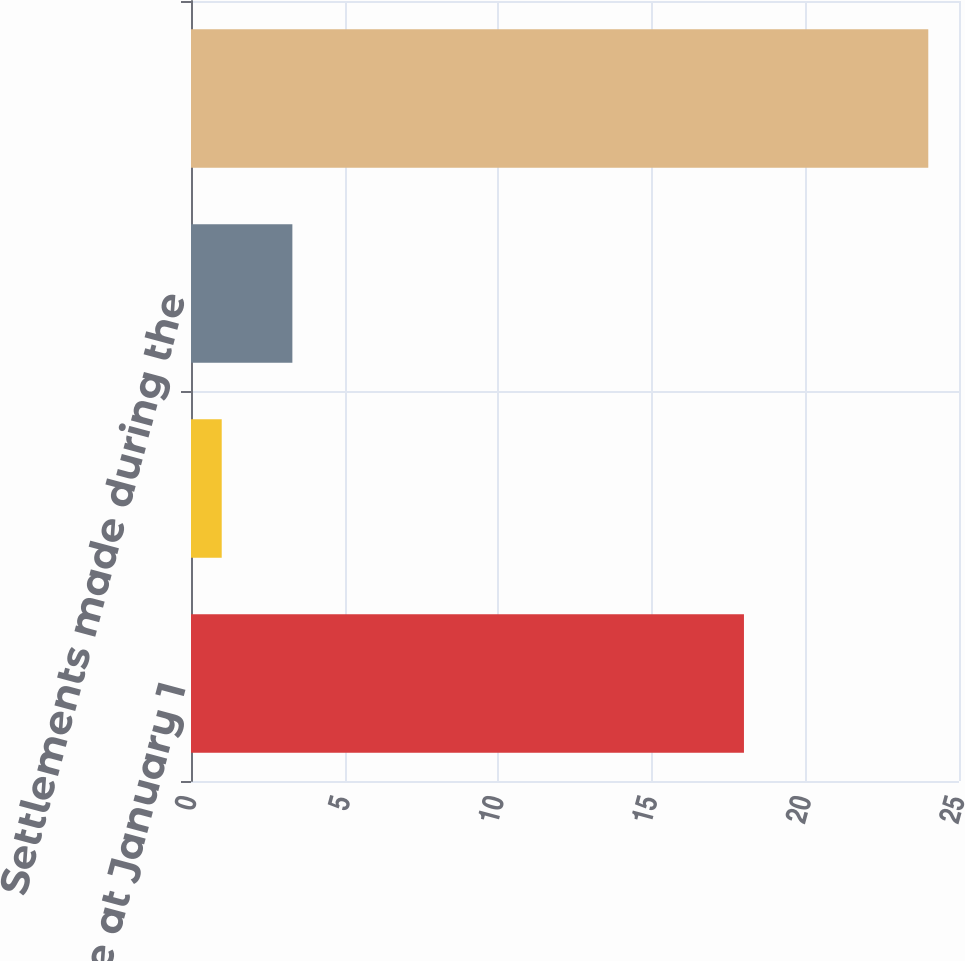Convert chart. <chart><loc_0><loc_0><loc_500><loc_500><bar_chart><fcel>Balance at January 1<fcel>Adjustments for warranties<fcel>Settlements made during the<fcel>Balance at December 31<nl><fcel>18<fcel>1<fcel>3.3<fcel>24<nl></chart> 